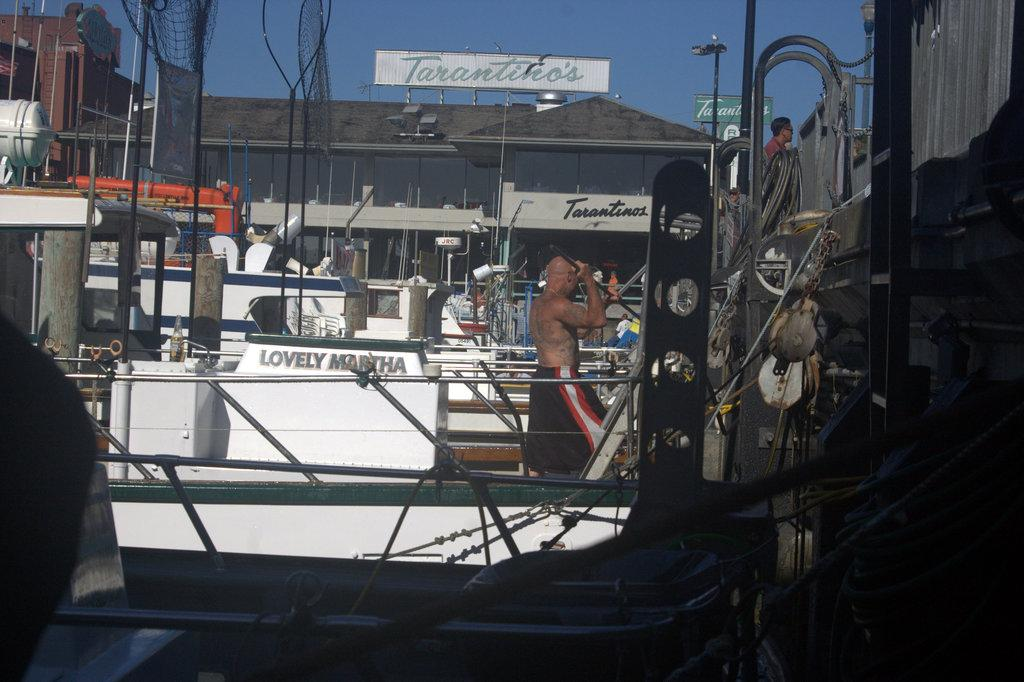What is the main subject of the image? There is a man in the image. What is the man wearing, or not wearing, in the image? The man is not wearing a shirt in the image. What is the man doing in the image? The man is walking in a boat in the image. Where is the image set? The image appears to be set in a shipyard. What can be seen in the background of the image? There are many boats and a building visible in the background of the image. What part of the natural environment is visible in the image? The sky is visible above the building in the background. Where is the cellar located in the image? There is no cellar present in the image. What type of can is being used by the man in the image? The man is not using a can in the image; he is walking in a boat. 